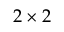Convert formula to latex. <formula><loc_0><loc_0><loc_500><loc_500>2 \times 2</formula> 